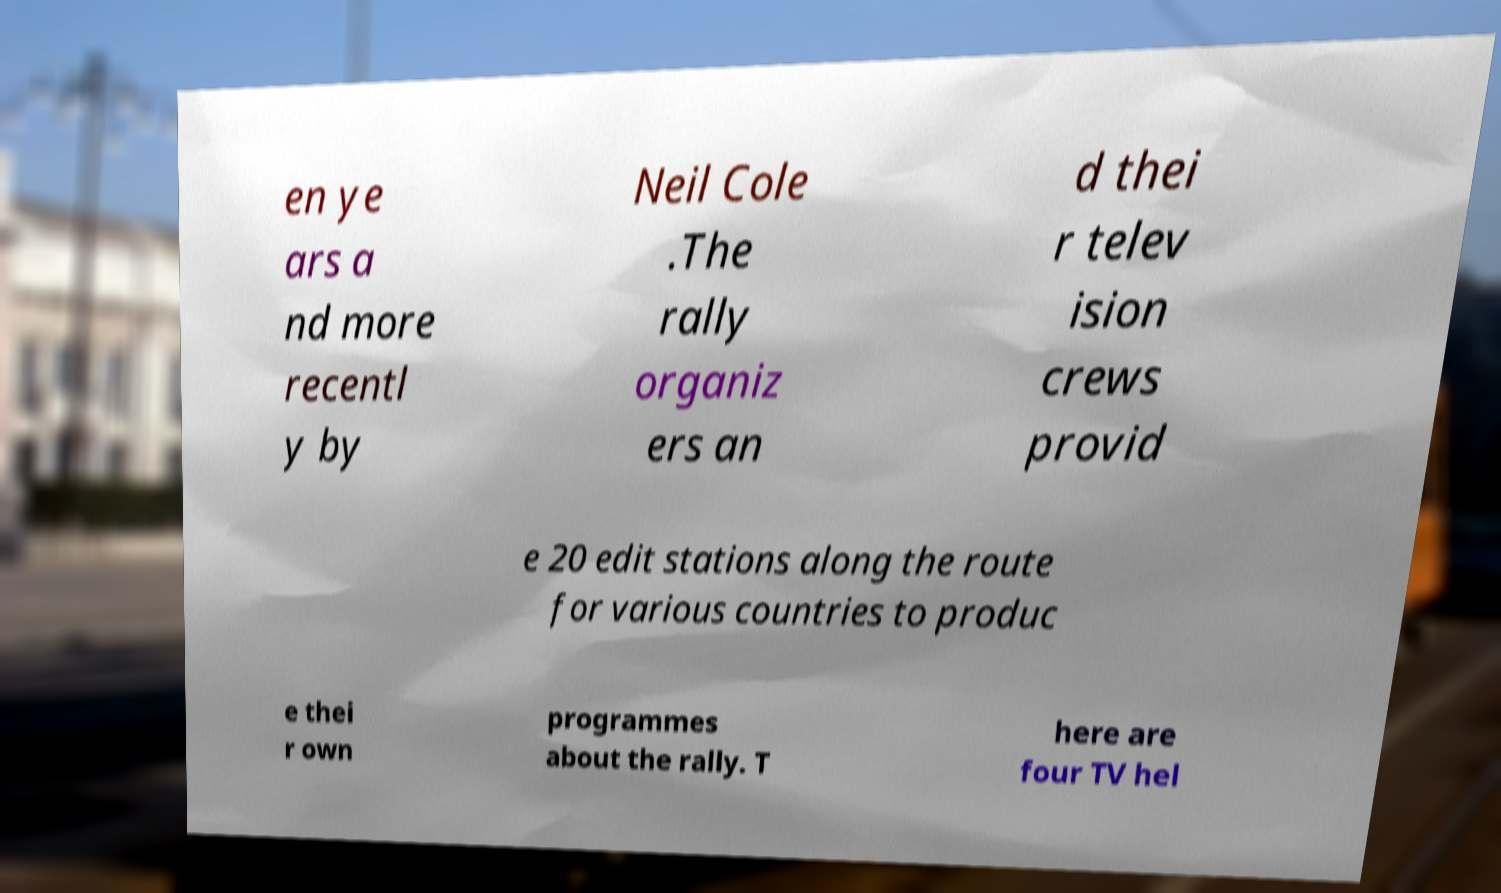For documentation purposes, I need the text within this image transcribed. Could you provide that? en ye ars a nd more recentl y by Neil Cole .The rally organiz ers an d thei r telev ision crews provid e 20 edit stations along the route for various countries to produc e thei r own programmes about the rally. T here are four TV hel 